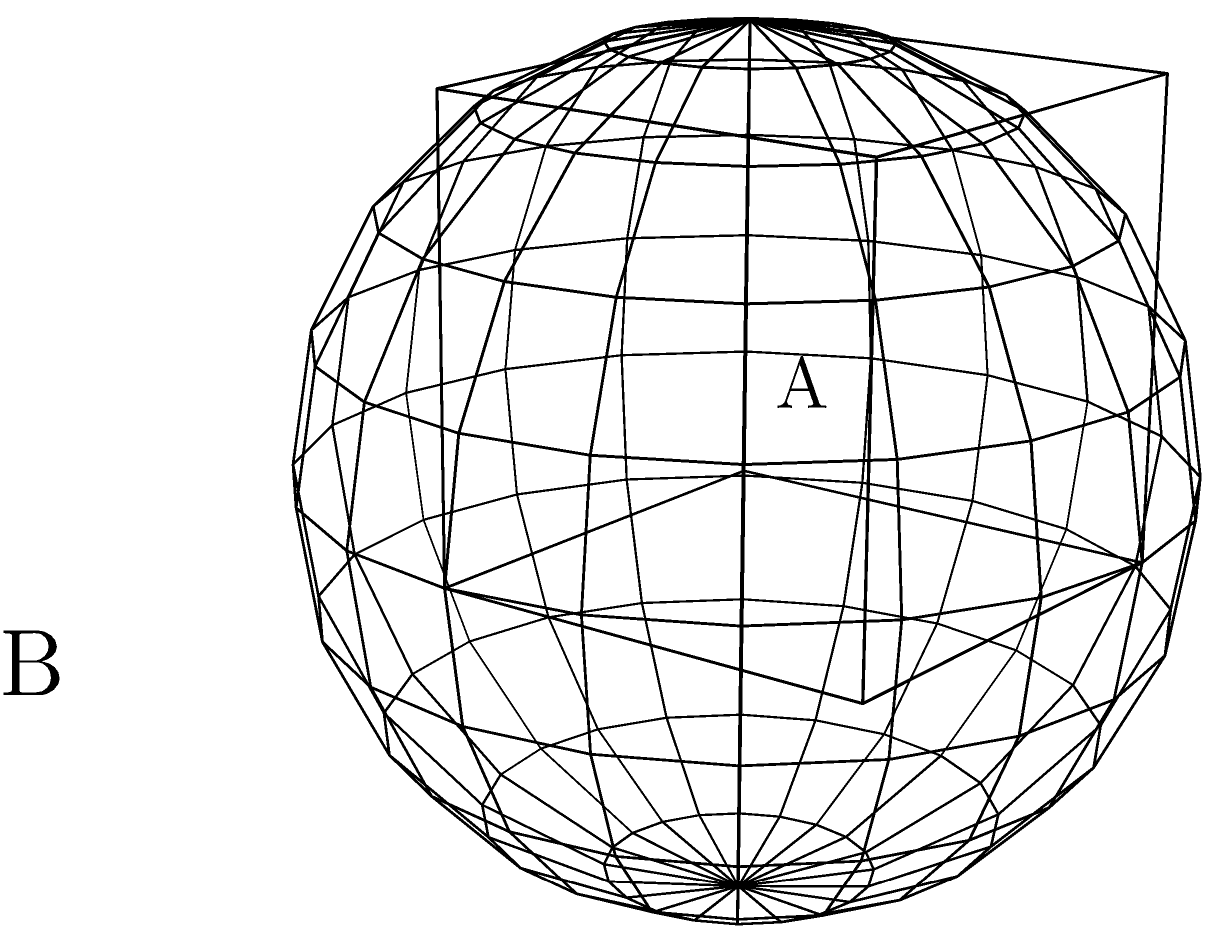As a 3D modeler, you're working on a project that involves classifying basic geometric shapes based on their wireframe representations. Given the two wireframe models shown above, labeled A and B, which shape is more likely to have a higher number of vertices in its fully rendered 3D model, and why? To answer this question, we need to analyze the characteristics of both wireframe models:

1. Model A (Cube):
   - Has 8 distinct vertices
   - Consists of straight edges connecting these vertices
   - In a fully rendered 3D model, the cube would maintain these 8 vertices

2. Model B (Sphere):
   - Appears to have many more vertices distributed across its surface
   - The wireframe shows a grid-like structure approximating a curved surface
   - In a fully rendered 3D model, the sphere would require even more vertices to achieve a smooth, curved appearance

Step-by-step reasoning:
1. The cube (A) has a fixed number of vertices (8) regardless of its resolution.
2. The sphere (B) is an approximation of a curved surface, which requires more vertices to represent accurately.
3. As the resolution of the sphere increases, the number of vertices will also increase to better approximate the smooth curvature.
4. In 3D modeling, curved surfaces typically require more polygons (and thus more vertices) than flat surfaces to appear smooth.
5. The sphere's complexity increases quadratically with resolution, while the cube's remains constant.

Therefore, the sphere (B) is more likely to have a higher number of vertices in its fully rendered 3D model because it needs to approximate a smooth, curved surface, which requires more geometric detail than the flat surfaces of a cube.
Answer: Sphere (B) 